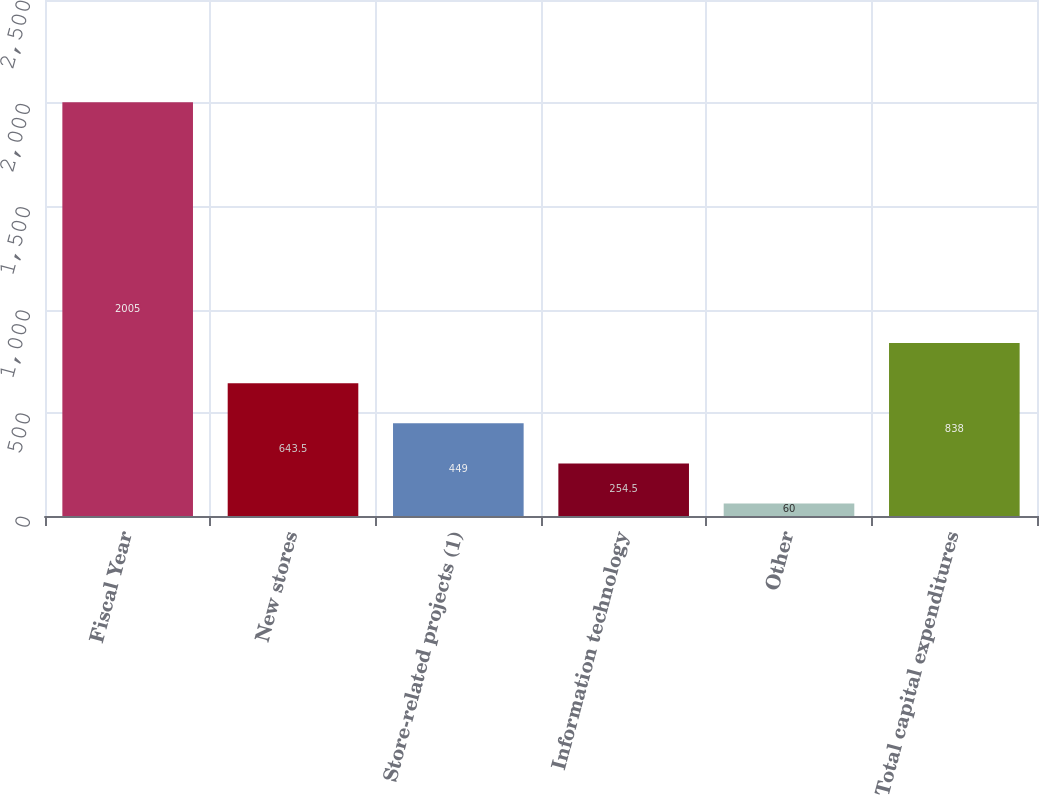Convert chart. <chart><loc_0><loc_0><loc_500><loc_500><bar_chart><fcel>Fiscal Year<fcel>New stores<fcel>Store-related projects (1)<fcel>Information technology<fcel>Other<fcel>Total capital expenditures<nl><fcel>2005<fcel>643.5<fcel>449<fcel>254.5<fcel>60<fcel>838<nl></chart> 